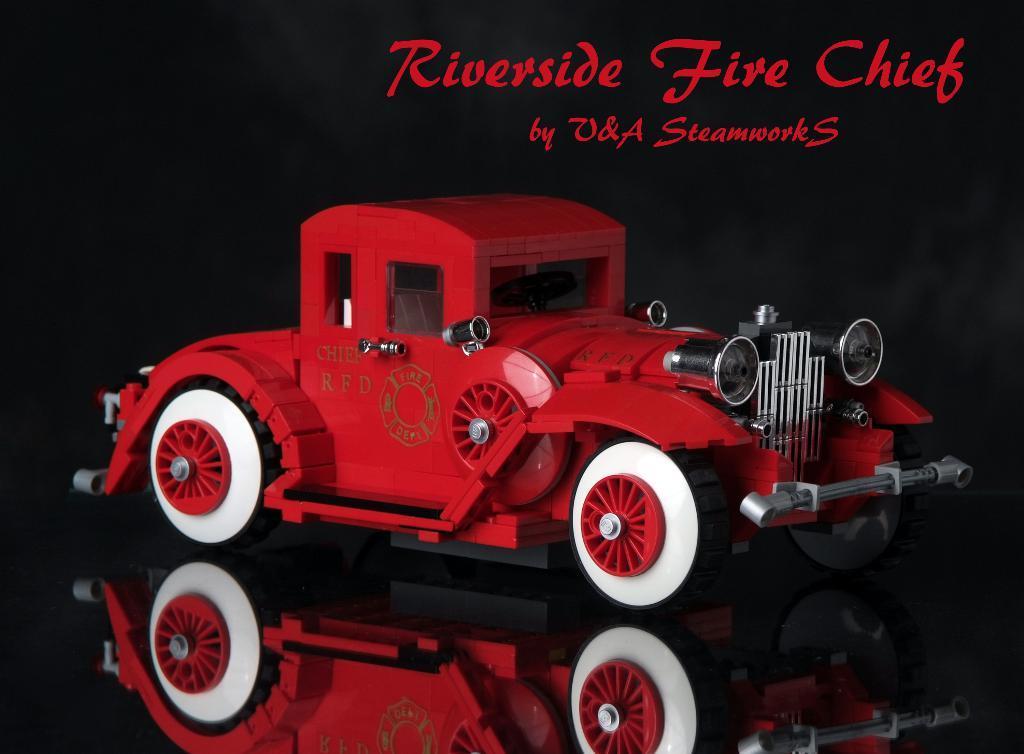Describe this image in one or two sentences. In the center of the image we can see a toy car. At the top there is text. 